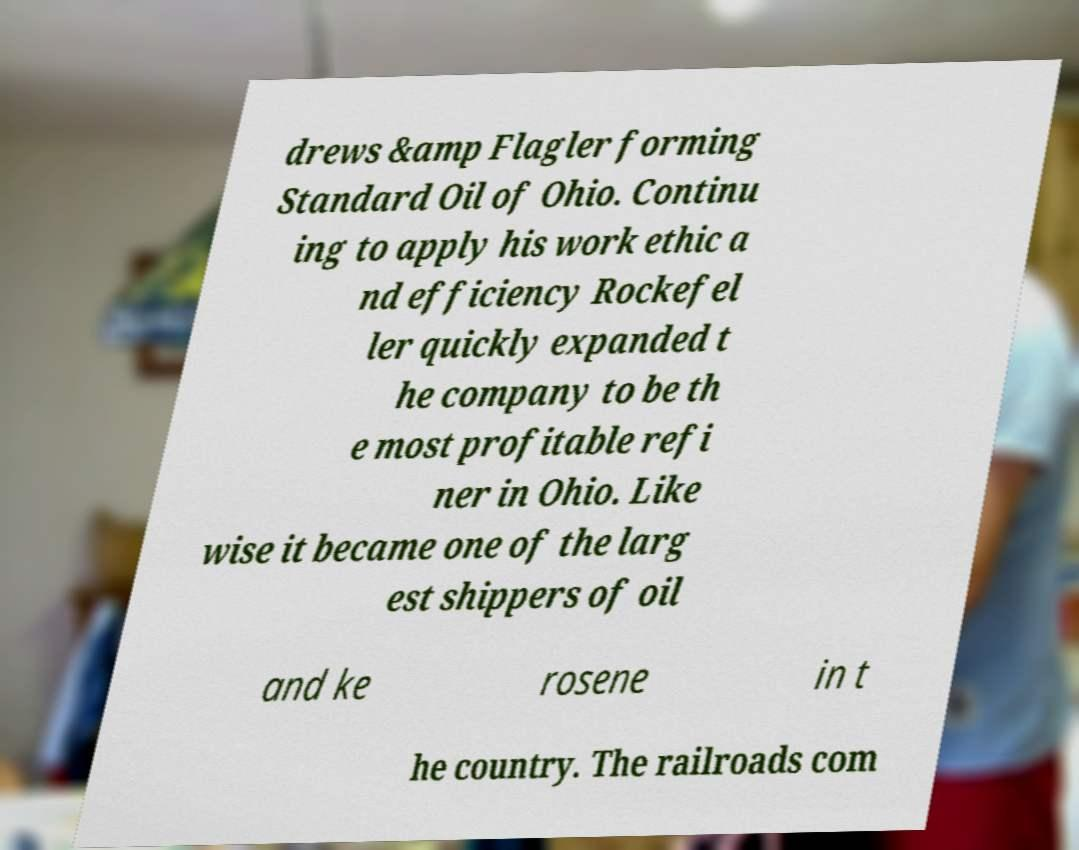Could you assist in decoding the text presented in this image and type it out clearly? drews &amp Flagler forming Standard Oil of Ohio. Continu ing to apply his work ethic a nd efficiency Rockefel ler quickly expanded t he company to be th e most profitable refi ner in Ohio. Like wise it became one of the larg est shippers of oil and ke rosene in t he country. The railroads com 